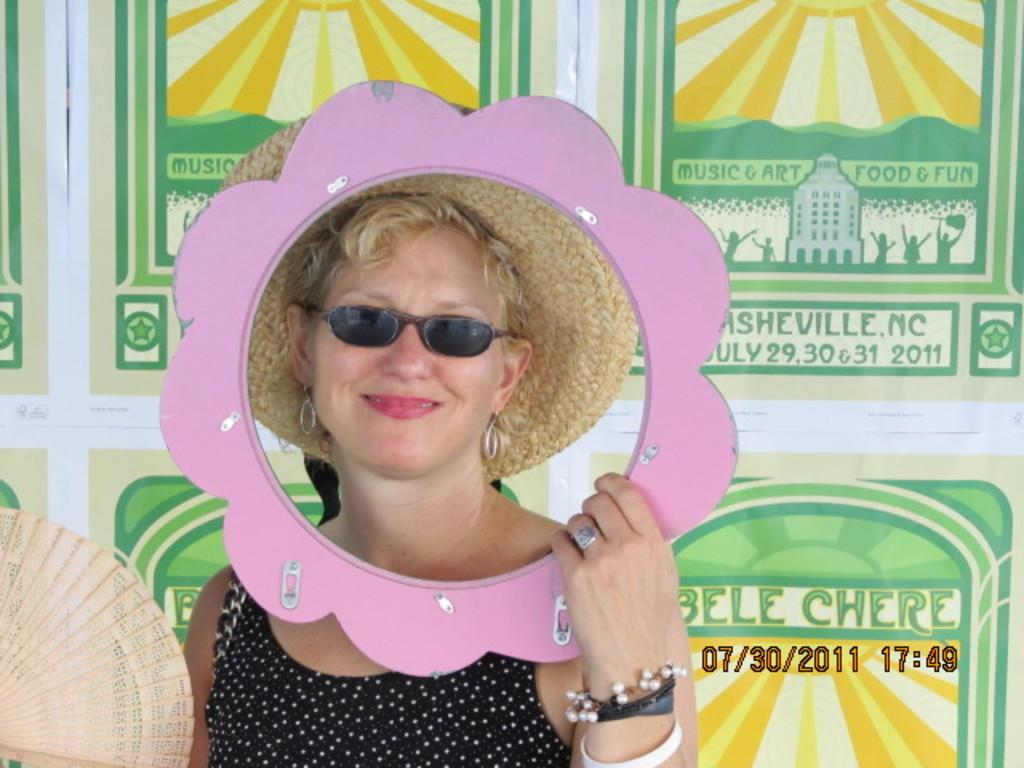Who is the main subject in the image? There is a woman in the image. What is the woman wearing on her head? The woman is wearing a cream color hat. What type of eyewear is the woman wearing? The woman is wearing black color goggles. What color is the dress the woman is wearing? The woman is wearing a black color dress. What can be seen in the background of the image? There are posters visible in the background of the image. How is the honey being distributed among the crowd in the image? There is no honey or crowd present in the image; it features a woman wearing a hat, goggles, and a dress, with posters visible in the background. 